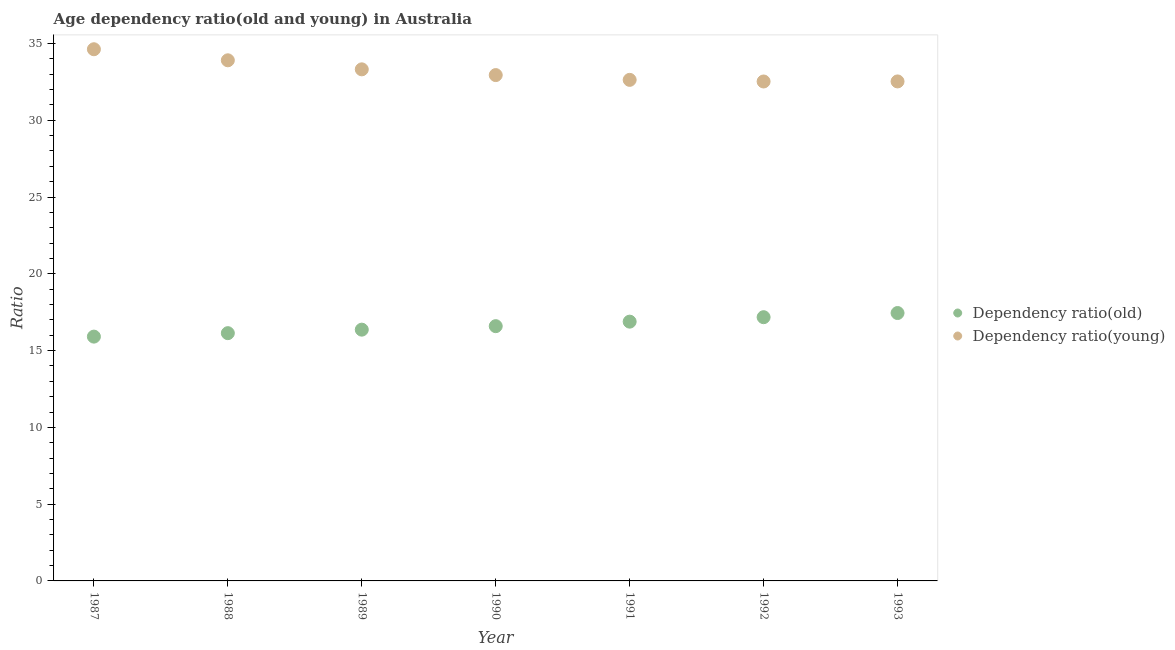How many different coloured dotlines are there?
Your response must be concise. 2. What is the age dependency ratio(young) in 1987?
Offer a terse response. 34.63. Across all years, what is the maximum age dependency ratio(young)?
Provide a short and direct response. 34.63. Across all years, what is the minimum age dependency ratio(old)?
Your answer should be very brief. 15.91. What is the total age dependency ratio(old) in the graph?
Keep it short and to the point. 116.51. What is the difference between the age dependency ratio(young) in 1988 and that in 1991?
Give a very brief answer. 1.27. What is the difference between the age dependency ratio(old) in 1993 and the age dependency ratio(young) in 1992?
Provide a short and direct response. -15.08. What is the average age dependency ratio(young) per year?
Make the answer very short. 33.21. In the year 1993, what is the difference between the age dependency ratio(young) and age dependency ratio(old)?
Provide a succinct answer. 15.08. What is the ratio of the age dependency ratio(old) in 1990 to that in 1991?
Your answer should be compact. 0.98. Is the age dependency ratio(old) in 1991 less than that in 1993?
Offer a very short reply. Yes. Is the difference between the age dependency ratio(old) in 1990 and 1991 greater than the difference between the age dependency ratio(young) in 1990 and 1991?
Ensure brevity in your answer.  No. What is the difference between the highest and the second highest age dependency ratio(old)?
Provide a succinct answer. 0.27. What is the difference between the highest and the lowest age dependency ratio(young)?
Provide a succinct answer. 2.1. In how many years, is the age dependency ratio(young) greater than the average age dependency ratio(young) taken over all years?
Offer a terse response. 3. Is the sum of the age dependency ratio(old) in 1987 and 1991 greater than the maximum age dependency ratio(young) across all years?
Offer a terse response. No. Does the age dependency ratio(old) monotonically increase over the years?
Provide a succinct answer. Yes. Is the age dependency ratio(young) strictly less than the age dependency ratio(old) over the years?
Make the answer very short. No. How many dotlines are there?
Provide a short and direct response. 2. What is the difference between two consecutive major ticks on the Y-axis?
Offer a very short reply. 5. Are the values on the major ticks of Y-axis written in scientific E-notation?
Your response must be concise. No. Does the graph contain any zero values?
Provide a succinct answer. No. Does the graph contain grids?
Keep it short and to the point. No. Where does the legend appear in the graph?
Ensure brevity in your answer.  Center right. How many legend labels are there?
Make the answer very short. 2. What is the title of the graph?
Ensure brevity in your answer.  Age dependency ratio(old and young) in Australia. What is the label or title of the Y-axis?
Your answer should be compact. Ratio. What is the Ratio of Dependency ratio(old) in 1987?
Your response must be concise. 15.91. What is the Ratio of Dependency ratio(young) in 1987?
Your answer should be very brief. 34.63. What is the Ratio of Dependency ratio(old) in 1988?
Ensure brevity in your answer.  16.14. What is the Ratio of Dependency ratio(young) in 1988?
Keep it short and to the point. 33.91. What is the Ratio of Dependency ratio(old) in 1989?
Keep it short and to the point. 16.36. What is the Ratio of Dependency ratio(young) in 1989?
Make the answer very short. 33.32. What is the Ratio of Dependency ratio(old) in 1990?
Keep it short and to the point. 16.59. What is the Ratio of Dependency ratio(young) in 1990?
Offer a terse response. 32.94. What is the Ratio of Dependency ratio(old) in 1991?
Your answer should be compact. 16.89. What is the Ratio of Dependency ratio(young) in 1991?
Give a very brief answer. 32.63. What is the Ratio in Dependency ratio(old) in 1992?
Give a very brief answer. 17.18. What is the Ratio of Dependency ratio(young) in 1992?
Your answer should be compact. 32.53. What is the Ratio of Dependency ratio(old) in 1993?
Ensure brevity in your answer.  17.45. What is the Ratio in Dependency ratio(young) in 1993?
Provide a short and direct response. 32.53. Across all years, what is the maximum Ratio of Dependency ratio(old)?
Offer a terse response. 17.45. Across all years, what is the maximum Ratio of Dependency ratio(young)?
Keep it short and to the point. 34.63. Across all years, what is the minimum Ratio in Dependency ratio(old)?
Give a very brief answer. 15.91. Across all years, what is the minimum Ratio in Dependency ratio(young)?
Your answer should be very brief. 32.53. What is the total Ratio in Dependency ratio(old) in the graph?
Give a very brief answer. 116.51. What is the total Ratio in Dependency ratio(young) in the graph?
Ensure brevity in your answer.  232.49. What is the difference between the Ratio in Dependency ratio(old) in 1987 and that in 1988?
Your response must be concise. -0.23. What is the difference between the Ratio of Dependency ratio(young) in 1987 and that in 1988?
Offer a terse response. 0.72. What is the difference between the Ratio of Dependency ratio(old) in 1987 and that in 1989?
Provide a short and direct response. -0.45. What is the difference between the Ratio in Dependency ratio(young) in 1987 and that in 1989?
Keep it short and to the point. 1.31. What is the difference between the Ratio of Dependency ratio(old) in 1987 and that in 1990?
Provide a short and direct response. -0.68. What is the difference between the Ratio of Dependency ratio(young) in 1987 and that in 1990?
Offer a terse response. 1.68. What is the difference between the Ratio of Dependency ratio(old) in 1987 and that in 1991?
Your answer should be compact. -0.98. What is the difference between the Ratio of Dependency ratio(young) in 1987 and that in 1991?
Provide a succinct answer. 1.99. What is the difference between the Ratio of Dependency ratio(old) in 1987 and that in 1992?
Offer a terse response. -1.27. What is the difference between the Ratio of Dependency ratio(young) in 1987 and that in 1992?
Your response must be concise. 2.1. What is the difference between the Ratio in Dependency ratio(old) in 1987 and that in 1993?
Offer a very short reply. -1.54. What is the difference between the Ratio of Dependency ratio(young) in 1987 and that in 1993?
Ensure brevity in your answer.  2.1. What is the difference between the Ratio in Dependency ratio(old) in 1988 and that in 1989?
Offer a terse response. -0.23. What is the difference between the Ratio in Dependency ratio(young) in 1988 and that in 1989?
Offer a terse response. 0.59. What is the difference between the Ratio of Dependency ratio(old) in 1988 and that in 1990?
Give a very brief answer. -0.46. What is the difference between the Ratio of Dependency ratio(young) in 1988 and that in 1990?
Your response must be concise. 0.96. What is the difference between the Ratio of Dependency ratio(old) in 1988 and that in 1991?
Give a very brief answer. -0.75. What is the difference between the Ratio of Dependency ratio(young) in 1988 and that in 1991?
Keep it short and to the point. 1.27. What is the difference between the Ratio in Dependency ratio(old) in 1988 and that in 1992?
Make the answer very short. -1.04. What is the difference between the Ratio in Dependency ratio(young) in 1988 and that in 1992?
Provide a short and direct response. 1.38. What is the difference between the Ratio in Dependency ratio(old) in 1988 and that in 1993?
Keep it short and to the point. -1.31. What is the difference between the Ratio in Dependency ratio(young) in 1988 and that in 1993?
Provide a short and direct response. 1.38. What is the difference between the Ratio in Dependency ratio(old) in 1989 and that in 1990?
Offer a terse response. -0.23. What is the difference between the Ratio in Dependency ratio(young) in 1989 and that in 1990?
Provide a short and direct response. 0.37. What is the difference between the Ratio of Dependency ratio(old) in 1989 and that in 1991?
Give a very brief answer. -0.52. What is the difference between the Ratio in Dependency ratio(young) in 1989 and that in 1991?
Provide a succinct answer. 0.69. What is the difference between the Ratio in Dependency ratio(old) in 1989 and that in 1992?
Give a very brief answer. -0.81. What is the difference between the Ratio of Dependency ratio(young) in 1989 and that in 1992?
Your answer should be very brief. 0.79. What is the difference between the Ratio in Dependency ratio(old) in 1989 and that in 1993?
Your answer should be compact. -1.08. What is the difference between the Ratio of Dependency ratio(young) in 1989 and that in 1993?
Offer a terse response. 0.79. What is the difference between the Ratio of Dependency ratio(old) in 1990 and that in 1991?
Give a very brief answer. -0.29. What is the difference between the Ratio in Dependency ratio(young) in 1990 and that in 1991?
Give a very brief answer. 0.31. What is the difference between the Ratio of Dependency ratio(old) in 1990 and that in 1992?
Your response must be concise. -0.58. What is the difference between the Ratio in Dependency ratio(young) in 1990 and that in 1992?
Provide a short and direct response. 0.42. What is the difference between the Ratio in Dependency ratio(old) in 1990 and that in 1993?
Your response must be concise. -0.86. What is the difference between the Ratio of Dependency ratio(young) in 1990 and that in 1993?
Give a very brief answer. 0.41. What is the difference between the Ratio in Dependency ratio(old) in 1991 and that in 1992?
Provide a succinct answer. -0.29. What is the difference between the Ratio in Dependency ratio(young) in 1991 and that in 1992?
Make the answer very short. 0.11. What is the difference between the Ratio in Dependency ratio(old) in 1991 and that in 1993?
Your answer should be very brief. -0.56. What is the difference between the Ratio in Dependency ratio(young) in 1991 and that in 1993?
Your answer should be very brief. 0.1. What is the difference between the Ratio in Dependency ratio(old) in 1992 and that in 1993?
Your response must be concise. -0.27. What is the difference between the Ratio in Dependency ratio(young) in 1992 and that in 1993?
Ensure brevity in your answer.  -0. What is the difference between the Ratio of Dependency ratio(old) in 1987 and the Ratio of Dependency ratio(young) in 1988?
Keep it short and to the point. -18. What is the difference between the Ratio in Dependency ratio(old) in 1987 and the Ratio in Dependency ratio(young) in 1989?
Give a very brief answer. -17.41. What is the difference between the Ratio of Dependency ratio(old) in 1987 and the Ratio of Dependency ratio(young) in 1990?
Keep it short and to the point. -17.03. What is the difference between the Ratio in Dependency ratio(old) in 1987 and the Ratio in Dependency ratio(young) in 1991?
Offer a very short reply. -16.72. What is the difference between the Ratio of Dependency ratio(old) in 1987 and the Ratio of Dependency ratio(young) in 1992?
Keep it short and to the point. -16.62. What is the difference between the Ratio in Dependency ratio(old) in 1987 and the Ratio in Dependency ratio(young) in 1993?
Offer a very short reply. -16.62. What is the difference between the Ratio of Dependency ratio(old) in 1988 and the Ratio of Dependency ratio(young) in 1989?
Your answer should be compact. -17.18. What is the difference between the Ratio of Dependency ratio(old) in 1988 and the Ratio of Dependency ratio(young) in 1990?
Your response must be concise. -16.81. What is the difference between the Ratio of Dependency ratio(old) in 1988 and the Ratio of Dependency ratio(young) in 1991?
Keep it short and to the point. -16.5. What is the difference between the Ratio in Dependency ratio(old) in 1988 and the Ratio in Dependency ratio(young) in 1992?
Offer a very short reply. -16.39. What is the difference between the Ratio of Dependency ratio(old) in 1988 and the Ratio of Dependency ratio(young) in 1993?
Offer a very short reply. -16.39. What is the difference between the Ratio in Dependency ratio(old) in 1989 and the Ratio in Dependency ratio(young) in 1990?
Offer a very short reply. -16.58. What is the difference between the Ratio of Dependency ratio(old) in 1989 and the Ratio of Dependency ratio(young) in 1991?
Your response must be concise. -16.27. What is the difference between the Ratio in Dependency ratio(old) in 1989 and the Ratio in Dependency ratio(young) in 1992?
Give a very brief answer. -16.16. What is the difference between the Ratio of Dependency ratio(old) in 1989 and the Ratio of Dependency ratio(young) in 1993?
Your response must be concise. -16.17. What is the difference between the Ratio in Dependency ratio(old) in 1990 and the Ratio in Dependency ratio(young) in 1991?
Offer a very short reply. -16.04. What is the difference between the Ratio in Dependency ratio(old) in 1990 and the Ratio in Dependency ratio(young) in 1992?
Provide a short and direct response. -15.93. What is the difference between the Ratio of Dependency ratio(old) in 1990 and the Ratio of Dependency ratio(young) in 1993?
Offer a very short reply. -15.94. What is the difference between the Ratio of Dependency ratio(old) in 1991 and the Ratio of Dependency ratio(young) in 1992?
Your response must be concise. -15.64. What is the difference between the Ratio in Dependency ratio(old) in 1991 and the Ratio in Dependency ratio(young) in 1993?
Your answer should be compact. -15.65. What is the difference between the Ratio of Dependency ratio(old) in 1992 and the Ratio of Dependency ratio(young) in 1993?
Ensure brevity in your answer.  -15.36. What is the average Ratio in Dependency ratio(old) per year?
Offer a very short reply. 16.64. What is the average Ratio of Dependency ratio(young) per year?
Your answer should be very brief. 33.21. In the year 1987, what is the difference between the Ratio of Dependency ratio(old) and Ratio of Dependency ratio(young)?
Provide a succinct answer. -18.72. In the year 1988, what is the difference between the Ratio of Dependency ratio(old) and Ratio of Dependency ratio(young)?
Your answer should be compact. -17.77. In the year 1989, what is the difference between the Ratio in Dependency ratio(old) and Ratio in Dependency ratio(young)?
Keep it short and to the point. -16.95. In the year 1990, what is the difference between the Ratio in Dependency ratio(old) and Ratio in Dependency ratio(young)?
Make the answer very short. -16.35. In the year 1991, what is the difference between the Ratio in Dependency ratio(old) and Ratio in Dependency ratio(young)?
Ensure brevity in your answer.  -15.75. In the year 1992, what is the difference between the Ratio of Dependency ratio(old) and Ratio of Dependency ratio(young)?
Offer a very short reply. -15.35. In the year 1993, what is the difference between the Ratio of Dependency ratio(old) and Ratio of Dependency ratio(young)?
Your answer should be compact. -15.08. What is the ratio of the Ratio of Dependency ratio(young) in 1987 to that in 1988?
Keep it short and to the point. 1.02. What is the ratio of the Ratio of Dependency ratio(old) in 1987 to that in 1989?
Provide a short and direct response. 0.97. What is the ratio of the Ratio of Dependency ratio(young) in 1987 to that in 1989?
Provide a succinct answer. 1.04. What is the ratio of the Ratio in Dependency ratio(old) in 1987 to that in 1990?
Offer a terse response. 0.96. What is the ratio of the Ratio in Dependency ratio(young) in 1987 to that in 1990?
Make the answer very short. 1.05. What is the ratio of the Ratio of Dependency ratio(old) in 1987 to that in 1991?
Your answer should be very brief. 0.94. What is the ratio of the Ratio in Dependency ratio(young) in 1987 to that in 1991?
Provide a short and direct response. 1.06. What is the ratio of the Ratio of Dependency ratio(old) in 1987 to that in 1992?
Keep it short and to the point. 0.93. What is the ratio of the Ratio of Dependency ratio(young) in 1987 to that in 1992?
Provide a succinct answer. 1.06. What is the ratio of the Ratio of Dependency ratio(old) in 1987 to that in 1993?
Make the answer very short. 0.91. What is the ratio of the Ratio in Dependency ratio(young) in 1987 to that in 1993?
Offer a very short reply. 1.06. What is the ratio of the Ratio in Dependency ratio(old) in 1988 to that in 1989?
Your answer should be very brief. 0.99. What is the ratio of the Ratio of Dependency ratio(young) in 1988 to that in 1989?
Keep it short and to the point. 1.02. What is the ratio of the Ratio in Dependency ratio(old) in 1988 to that in 1990?
Provide a succinct answer. 0.97. What is the ratio of the Ratio in Dependency ratio(young) in 1988 to that in 1990?
Provide a short and direct response. 1.03. What is the ratio of the Ratio in Dependency ratio(old) in 1988 to that in 1991?
Provide a succinct answer. 0.96. What is the ratio of the Ratio of Dependency ratio(young) in 1988 to that in 1991?
Offer a terse response. 1.04. What is the ratio of the Ratio of Dependency ratio(old) in 1988 to that in 1992?
Ensure brevity in your answer.  0.94. What is the ratio of the Ratio of Dependency ratio(young) in 1988 to that in 1992?
Your answer should be very brief. 1.04. What is the ratio of the Ratio of Dependency ratio(old) in 1988 to that in 1993?
Offer a very short reply. 0.92. What is the ratio of the Ratio in Dependency ratio(young) in 1988 to that in 1993?
Offer a very short reply. 1.04. What is the ratio of the Ratio in Dependency ratio(old) in 1989 to that in 1990?
Provide a short and direct response. 0.99. What is the ratio of the Ratio in Dependency ratio(young) in 1989 to that in 1990?
Offer a terse response. 1.01. What is the ratio of the Ratio of Dependency ratio(old) in 1989 to that in 1991?
Give a very brief answer. 0.97. What is the ratio of the Ratio of Dependency ratio(old) in 1989 to that in 1992?
Your response must be concise. 0.95. What is the ratio of the Ratio of Dependency ratio(young) in 1989 to that in 1992?
Your response must be concise. 1.02. What is the ratio of the Ratio of Dependency ratio(old) in 1989 to that in 1993?
Your answer should be very brief. 0.94. What is the ratio of the Ratio of Dependency ratio(young) in 1989 to that in 1993?
Make the answer very short. 1.02. What is the ratio of the Ratio of Dependency ratio(old) in 1990 to that in 1991?
Offer a terse response. 0.98. What is the ratio of the Ratio in Dependency ratio(young) in 1990 to that in 1991?
Provide a succinct answer. 1.01. What is the ratio of the Ratio of Dependency ratio(young) in 1990 to that in 1992?
Offer a very short reply. 1.01. What is the ratio of the Ratio in Dependency ratio(old) in 1990 to that in 1993?
Offer a very short reply. 0.95. What is the ratio of the Ratio of Dependency ratio(young) in 1990 to that in 1993?
Your answer should be compact. 1.01. What is the ratio of the Ratio of Dependency ratio(old) in 1991 to that in 1992?
Offer a very short reply. 0.98. What is the ratio of the Ratio in Dependency ratio(young) in 1991 to that in 1992?
Ensure brevity in your answer.  1. What is the ratio of the Ratio in Dependency ratio(old) in 1991 to that in 1993?
Your response must be concise. 0.97. What is the ratio of the Ratio of Dependency ratio(young) in 1991 to that in 1993?
Offer a very short reply. 1. What is the ratio of the Ratio in Dependency ratio(old) in 1992 to that in 1993?
Offer a very short reply. 0.98. What is the difference between the highest and the second highest Ratio in Dependency ratio(old)?
Your answer should be very brief. 0.27. What is the difference between the highest and the second highest Ratio in Dependency ratio(young)?
Ensure brevity in your answer.  0.72. What is the difference between the highest and the lowest Ratio of Dependency ratio(old)?
Ensure brevity in your answer.  1.54. What is the difference between the highest and the lowest Ratio of Dependency ratio(young)?
Provide a short and direct response. 2.1. 